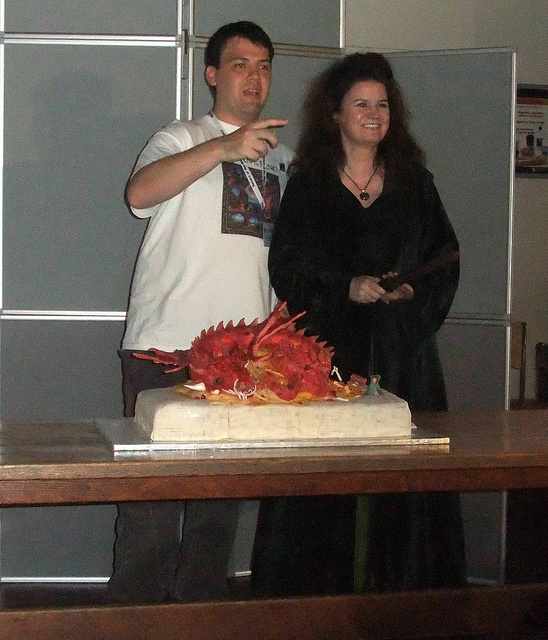Describe the objects in this image and their specific colors. I can see people in lightgray, black, brown, gray, and maroon tones, people in lightgray, darkgray, and brown tones, cake in lightgray, tan, brown, maroon, and beige tones, and knife in black and lightgray tones in this image. 